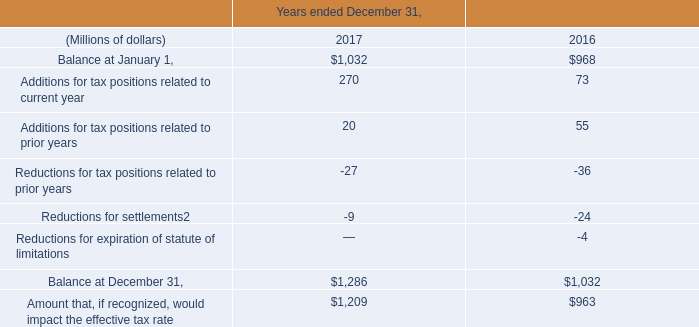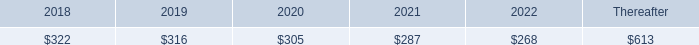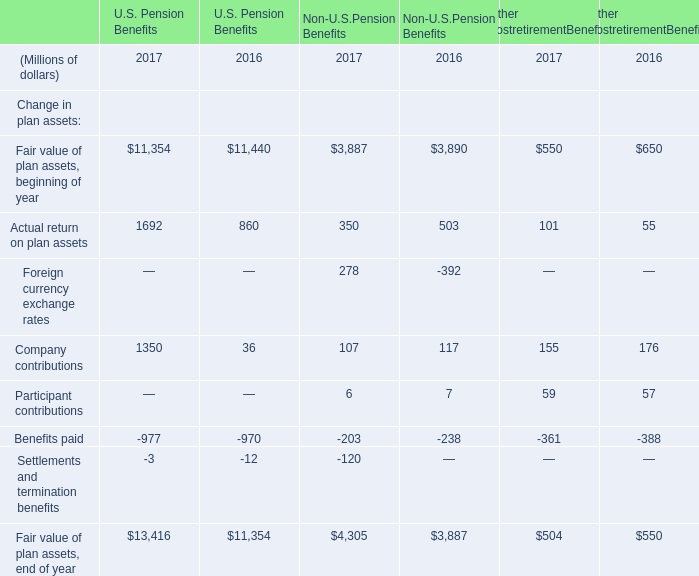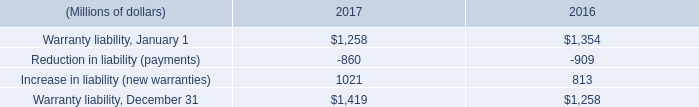assuming the same rate of change as in 2017 , what would the 2018 total amount of interest and penalties accrued equal in millions? 
Computations: ((157 / 120) * 157)
Answer: 205.40833. 